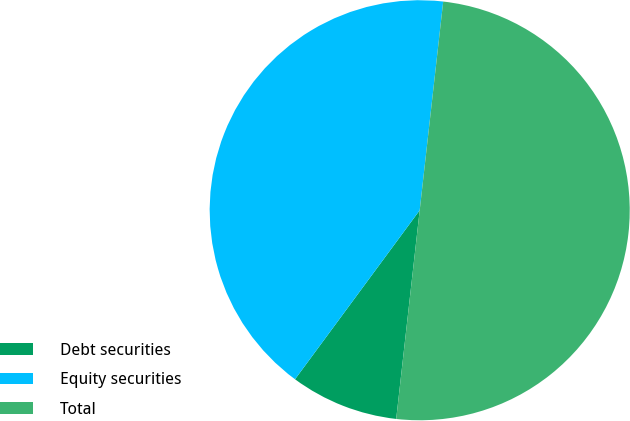<chart> <loc_0><loc_0><loc_500><loc_500><pie_chart><fcel>Debt securities<fcel>Equity securities<fcel>Total<nl><fcel>8.33%<fcel>41.67%<fcel>50.0%<nl></chart> 